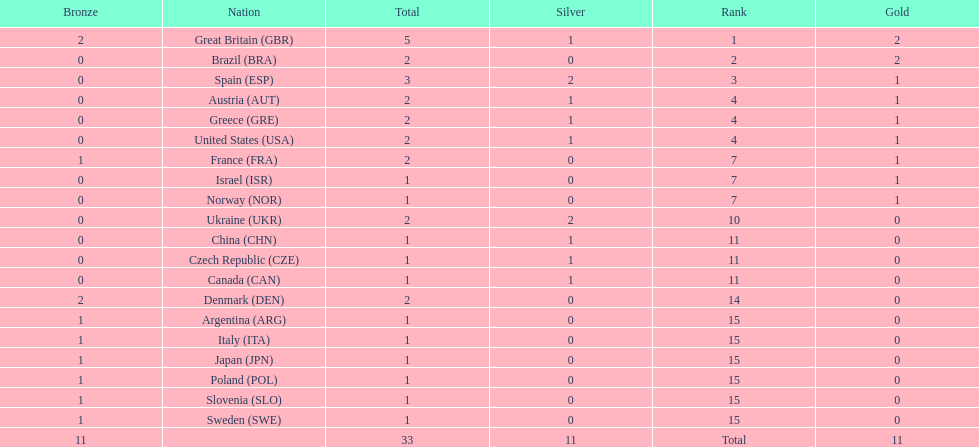Who has secured more gold medals in comparison to spain? Great Britain (GBR), Brazil (BRA). 